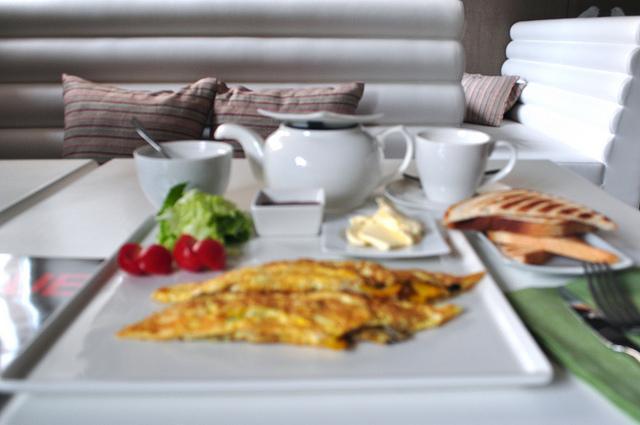Is the caption "The couch is far away from the sandwich." a true representation of the image?
Answer yes or no. No. 